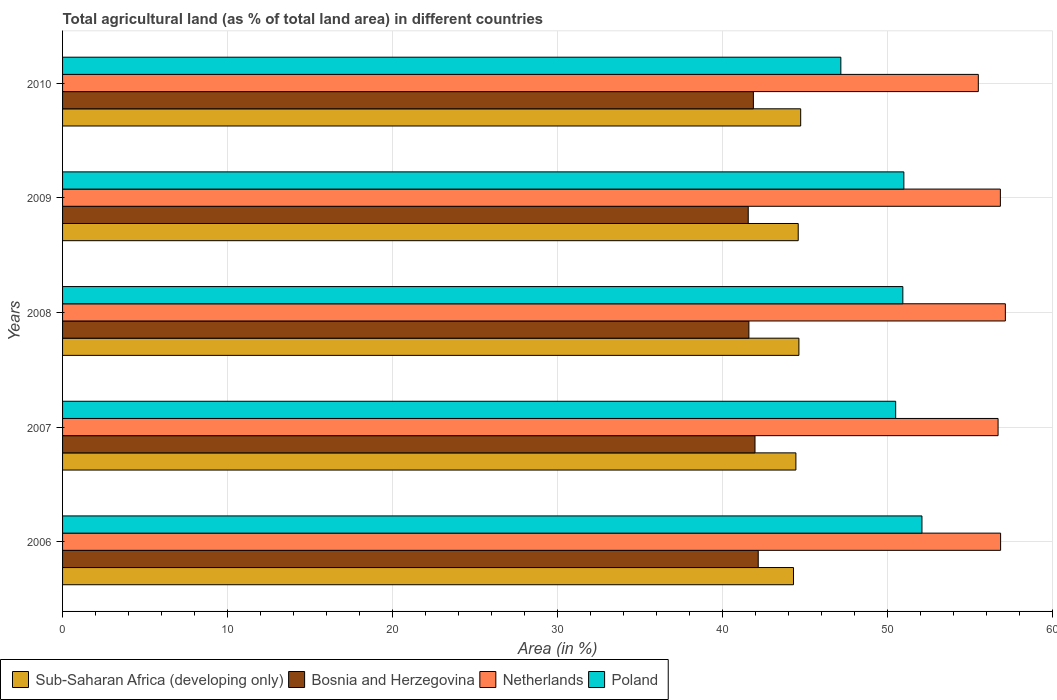How many different coloured bars are there?
Provide a succinct answer. 4. How many groups of bars are there?
Offer a terse response. 5. In how many cases, is the number of bars for a given year not equal to the number of legend labels?
Give a very brief answer. 0. What is the percentage of agricultural land in Sub-Saharan Africa (developing only) in 2010?
Give a very brief answer. 44.74. Across all years, what is the maximum percentage of agricultural land in Bosnia and Herzegovina?
Keep it short and to the point. 42.17. Across all years, what is the minimum percentage of agricultural land in Sub-Saharan Africa (developing only)?
Your response must be concise. 44.3. What is the total percentage of agricultural land in Bosnia and Herzegovina in the graph?
Keep it short and to the point. 209.18. What is the difference between the percentage of agricultural land in Bosnia and Herzegovina in 2006 and that in 2010?
Your answer should be compact. 0.29. What is the difference between the percentage of agricultural land in Netherlands in 2006 and the percentage of agricultural land in Sub-Saharan Africa (developing only) in 2009?
Make the answer very short. 12.27. What is the average percentage of agricultural land in Sub-Saharan Africa (developing only) per year?
Provide a short and direct response. 44.54. In the year 2007, what is the difference between the percentage of agricultural land in Netherlands and percentage of agricultural land in Bosnia and Herzegovina?
Offer a terse response. 14.73. What is the ratio of the percentage of agricultural land in Bosnia and Herzegovina in 2006 to that in 2008?
Keep it short and to the point. 1.01. Is the percentage of agricultural land in Bosnia and Herzegovina in 2009 less than that in 2010?
Ensure brevity in your answer.  Yes. Is the difference between the percentage of agricultural land in Netherlands in 2006 and 2009 greater than the difference between the percentage of agricultural land in Bosnia and Herzegovina in 2006 and 2009?
Your response must be concise. No. What is the difference between the highest and the second highest percentage of agricultural land in Sub-Saharan Africa (developing only)?
Provide a succinct answer. 0.11. What is the difference between the highest and the lowest percentage of agricultural land in Sub-Saharan Africa (developing only)?
Ensure brevity in your answer.  0.44. Is the sum of the percentage of agricultural land in Sub-Saharan Africa (developing only) in 2007 and 2009 greater than the maximum percentage of agricultural land in Netherlands across all years?
Give a very brief answer. Yes. Is it the case that in every year, the sum of the percentage of agricultural land in Netherlands and percentage of agricultural land in Bosnia and Herzegovina is greater than the percentage of agricultural land in Poland?
Keep it short and to the point. Yes. Are all the bars in the graph horizontal?
Offer a terse response. Yes. How many years are there in the graph?
Ensure brevity in your answer.  5. What is the difference between two consecutive major ticks on the X-axis?
Your response must be concise. 10. Are the values on the major ticks of X-axis written in scientific E-notation?
Give a very brief answer. No. Does the graph contain any zero values?
Offer a terse response. No. How are the legend labels stacked?
Your response must be concise. Horizontal. What is the title of the graph?
Offer a terse response. Total agricultural land (as % of total land area) in different countries. Does "Trinidad and Tobago" appear as one of the legend labels in the graph?
Provide a succinct answer. No. What is the label or title of the X-axis?
Give a very brief answer. Area (in %). What is the Area (in %) of Sub-Saharan Africa (developing only) in 2006?
Your answer should be compact. 44.3. What is the Area (in %) of Bosnia and Herzegovina in 2006?
Ensure brevity in your answer.  42.17. What is the Area (in %) of Netherlands in 2006?
Give a very brief answer. 56.86. What is the Area (in %) in Poland in 2006?
Offer a terse response. 52.09. What is the Area (in %) of Sub-Saharan Africa (developing only) in 2007?
Offer a terse response. 44.45. What is the Area (in %) of Bosnia and Herzegovina in 2007?
Provide a succinct answer. 41.97. What is the Area (in %) in Netherlands in 2007?
Offer a very short reply. 56.71. What is the Area (in %) in Poland in 2007?
Keep it short and to the point. 50.5. What is the Area (in %) of Sub-Saharan Africa (developing only) in 2008?
Make the answer very short. 44.63. What is the Area (in %) of Bosnia and Herzegovina in 2008?
Offer a terse response. 41.6. What is the Area (in %) in Netherlands in 2008?
Your response must be concise. 57.15. What is the Area (in %) in Poland in 2008?
Your answer should be very brief. 50.93. What is the Area (in %) of Sub-Saharan Africa (developing only) in 2009?
Your answer should be very brief. 44.59. What is the Area (in %) of Bosnia and Herzegovina in 2009?
Offer a very short reply. 41.56. What is the Area (in %) in Netherlands in 2009?
Keep it short and to the point. 56.85. What is the Area (in %) of Poland in 2009?
Make the answer very short. 51. What is the Area (in %) of Sub-Saharan Africa (developing only) in 2010?
Ensure brevity in your answer.  44.74. What is the Area (in %) in Bosnia and Herzegovina in 2010?
Keep it short and to the point. 41.88. What is the Area (in %) in Netherlands in 2010?
Provide a short and direct response. 55.51. What is the Area (in %) of Poland in 2010?
Ensure brevity in your answer.  47.18. Across all years, what is the maximum Area (in %) of Sub-Saharan Africa (developing only)?
Your answer should be compact. 44.74. Across all years, what is the maximum Area (in %) of Bosnia and Herzegovina?
Ensure brevity in your answer.  42.17. Across all years, what is the maximum Area (in %) of Netherlands?
Offer a terse response. 57.15. Across all years, what is the maximum Area (in %) of Poland?
Offer a very short reply. 52.09. Across all years, what is the minimum Area (in %) in Sub-Saharan Africa (developing only)?
Your answer should be very brief. 44.3. Across all years, what is the minimum Area (in %) of Bosnia and Herzegovina?
Your response must be concise. 41.56. Across all years, what is the minimum Area (in %) of Netherlands?
Your answer should be very brief. 55.51. Across all years, what is the minimum Area (in %) in Poland?
Provide a succinct answer. 47.18. What is the total Area (in %) of Sub-Saharan Africa (developing only) in the graph?
Offer a terse response. 222.72. What is the total Area (in %) of Bosnia and Herzegovina in the graph?
Your response must be concise. 209.18. What is the total Area (in %) of Netherlands in the graph?
Give a very brief answer. 283.07. What is the total Area (in %) of Poland in the graph?
Keep it short and to the point. 251.7. What is the difference between the Area (in %) in Sub-Saharan Africa (developing only) in 2006 and that in 2007?
Your answer should be compact. -0.15. What is the difference between the Area (in %) of Bosnia and Herzegovina in 2006 and that in 2007?
Your answer should be very brief. 0.2. What is the difference between the Area (in %) in Netherlands in 2006 and that in 2007?
Offer a terse response. 0.15. What is the difference between the Area (in %) of Poland in 2006 and that in 2007?
Your answer should be compact. 1.59. What is the difference between the Area (in %) of Sub-Saharan Africa (developing only) in 2006 and that in 2008?
Keep it short and to the point. -0.33. What is the difference between the Area (in %) in Bosnia and Herzegovina in 2006 and that in 2008?
Your answer should be very brief. 0.57. What is the difference between the Area (in %) in Netherlands in 2006 and that in 2008?
Keep it short and to the point. -0.29. What is the difference between the Area (in %) in Poland in 2006 and that in 2008?
Make the answer very short. 1.16. What is the difference between the Area (in %) in Sub-Saharan Africa (developing only) in 2006 and that in 2009?
Give a very brief answer. -0.29. What is the difference between the Area (in %) of Bosnia and Herzegovina in 2006 and that in 2009?
Keep it short and to the point. 0.61. What is the difference between the Area (in %) of Netherlands in 2006 and that in 2009?
Offer a terse response. 0.01. What is the difference between the Area (in %) in Poland in 2006 and that in 2009?
Offer a terse response. 1.1. What is the difference between the Area (in %) in Sub-Saharan Africa (developing only) in 2006 and that in 2010?
Make the answer very short. -0.44. What is the difference between the Area (in %) in Bosnia and Herzegovina in 2006 and that in 2010?
Your answer should be very brief. 0.29. What is the difference between the Area (in %) of Netherlands in 2006 and that in 2010?
Ensure brevity in your answer.  1.35. What is the difference between the Area (in %) of Poland in 2006 and that in 2010?
Ensure brevity in your answer.  4.92. What is the difference between the Area (in %) of Sub-Saharan Africa (developing only) in 2007 and that in 2008?
Ensure brevity in your answer.  -0.18. What is the difference between the Area (in %) in Bosnia and Herzegovina in 2007 and that in 2008?
Keep it short and to the point. 0.37. What is the difference between the Area (in %) of Netherlands in 2007 and that in 2008?
Give a very brief answer. -0.44. What is the difference between the Area (in %) of Poland in 2007 and that in 2008?
Give a very brief answer. -0.43. What is the difference between the Area (in %) in Sub-Saharan Africa (developing only) in 2007 and that in 2009?
Keep it short and to the point. -0.14. What is the difference between the Area (in %) in Bosnia and Herzegovina in 2007 and that in 2009?
Keep it short and to the point. 0.41. What is the difference between the Area (in %) in Netherlands in 2007 and that in 2009?
Your response must be concise. -0.14. What is the difference between the Area (in %) of Poland in 2007 and that in 2009?
Make the answer very short. -0.5. What is the difference between the Area (in %) of Sub-Saharan Africa (developing only) in 2007 and that in 2010?
Your answer should be very brief. -0.29. What is the difference between the Area (in %) in Bosnia and Herzegovina in 2007 and that in 2010?
Give a very brief answer. 0.1. What is the difference between the Area (in %) of Netherlands in 2007 and that in 2010?
Offer a very short reply. 1.2. What is the difference between the Area (in %) in Poland in 2007 and that in 2010?
Offer a terse response. 3.32. What is the difference between the Area (in %) in Sub-Saharan Africa (developing only) in 2008 and that in 2009?
Offer a terse response. 0.04. What is the difference between the Area (in %) of Bosnia and Herzegovina in 2008 and that in 2009?
Keep it short and to the point. 0.04. What is the difference between the Area (in %) in Netherlands in 2008 and that in 2009?
Give a very brief answer. 0.3. What is the difference between the Area (in %) in Poland in 2008 and that in 2009?
Make the answer very short. -0.06. What is the difference between the Area (in %) of Sub-Saharan Africa (developing only) in 2008 and that in 2010?
Offer a terse response. -0.11. What is the difference between the Area (in %) in Bosnia and Herzegovina in 2008 and that in 2010?
Keep it short and to the point. -0.27. What is the difference between the Area (in %) in Netherlands in 2008 and that in 2010?
Offer a very short reply. 1.64. What is the difference between the Area (in %) in Poland in 2008 and that in 2010?
Make the answer very short. 3.76. What is the difference between the Area (in %) of Sub-Saharan Africa (developing only) in 2009 and that in 2010?
Offer a very short reply. -0.15. What is the difference between the Area (in %) of Bosnia and Herzegovina in 2009 and that in 2010?
Keep it short and to the point. -0.31. What is the difference between the Area (in %) in Netherlands in 2009 and that in 2010?
Keep it short and to the point. 1.34. What is the difference between the Area (in %) in Poland in 2009 and that in 2010?
Offer a very short reply. 3.82. What is the difference between the Area (in %) of Sub-Saharan Africa (developing only) in 2006 and the Area (in %) of Bosnia and Herzegovina in 2007?
Your answer should be very brief. 2.33. What is the difference between the Area (in %) in Sub-Saharan Africa (developing only) in 2006 and the Area (in %) in Netherlands in 2007?
Your answer should be compact. -12.4. What is the difference between the Area (in %) in Sub-Saharan Africa (developing only) in 2006 and the Area (in %) in Poland in 2007?
Offer a terse response. -6.19. What is the difference between the Area (in %) of Bosnia and Herzegovina in 2006 and the Area (in %) of Netherlands in 2007?
Your answer should be very brief. -14.54. What is the difference between the Area (in %) of Bosnia and Herzegovina in 2006 and the Area (in %) of Poland in 2007?
Provide a succinct answer. -8.33. What is the difference between the Area (in %) in Netherlands in 2006 and the Area (in %) in Poland in 2007?
Ensure brevity in your answer.  6.36. What is the difference between the Area (in %) of Sub-Saharan Africa (developing only) in 2006 and the Area (in %) of Bosnia and Herzegovina in 2008?
Give a very brief answer. 2.7. What is the difference between the Area (in %) in Sub-Saharan Africa (developing only) in 2006 and the Area (in %) in Netherlands in 2008?
Ensure brevity in your answer.  -12.84. What is the difference between the Area (in %) in Sub-Saharan Africa (developing only) in 2006 and the Area (in %) in Poland in 2008?
Your answer should be compact. -6.63. What is the difference between the Area (in %) in Bosnia and Herzegovina in 2006 and the Area (in %) in Netherlands in 2008?
Your response must be concise. -14.98. What is the difference between the Area (in %) of Bosnia and Herzegovina in 2006 and the Area (in %) of Poland in 2008?
Provide a succinct answer. -8.77. What is the difference between the Area (in %) in Netherlands in 2006 and the Area (in %) in Poland in 2008?
Give a very brief answer. 5.93. What is the difference between the Area (in %) in Sub-Saharan Africa (developing only) in 2006 and the Area (in %) in Bosnia and Herzegovina in 2009?
Your response must be concise. 2.74. What is the difference between the Area (in %) in Sub-Saharan Africa (developing only) in 2006 and the Area (in %) in Netherlands in 2009?
Offer a terse response. -12.54. What is the difference between the Area (in %) in Sub-Saharan Africa (developing only) in 2006 and the Area (in %) in Poland in 2009?
Keep it short and to the point. -6.69. What is the difference between the Area (in %) in Bosnia and Herzegovina in 2006 and the Area (in %) in Netherlands in 2009?
Keep it short and to the point. -14.68. What is the difference between the Area (in %) of Bosnia and Herzegovina in 2006 and the Area (in %) of Poland in 2009?
Your answer should be compact. -8.83. What is the difference between the Area (in %) in Netherlands in 2006 and the Area (in %) in Poland in 2009?
Make the answer very short. 5.86. What is the difference between the Area (in %) in Sub-Saharan Africa (developing only) in 2006 and the Area (in %) in Bosnia and Herzegovina in 2010?
Provide a succinct answer. 2.43. What is the difference between the Area (in %) in Sub-Saharan Africa (developing only) in 2006 and the Area (in %) in Netherlands in 2010?
Provide a short and direct response. -11.2. What is the difference between the Area (in %) in Sub-Saharan Africa (developing only) in 2006 and the Area (in %) in Poland in 2010?
Ensure brevity in your answer.  -2.87. What is the difference between the Area (in %) in Bosnia and Herzegovina in 2006 and the Area (in %) in Netherlands in 2010?
Your answer should be very brief. -13.34. What is the difference between the Area (in %) of Bosnia and Herzegovina in 2006 and the Area (in %) of Poland in 2010?
Give a very brief answer. -5.01. What is the difference between the Area (in %) of Netherlands in 2006 and the Area (in %) of Poland in 2010?
Give a very brief answer. 9.68. What is the difference between the Area (in %) in Sub-Saharan Africa (developing only) in 2007 and the Area (in %) in Bosnia and Herzegovina in 2008?
Provide a succinct answer. 2.85. What is the difference between the Area (in %) of Sub-Saharan Africa (developing only) in 2007 and the Area (in %) of Netherlands in 2008?
Make the answer very short. -12.7. What is the difference between the Area (in %) in Sub-Saharan Africa (developing only) in 2007 and the Area (in %) in Poland in 2008?
Offer a terse response. -6.48. What is the difference between the Area (in %) of Bosnia and Herzegovina in 2007 and the Area (in %) of Netherlands in 2008?
Your response must be concise. -15.17. What is the difference between the Area (in %) in Bosnia and Herzegovina in 2007 and the Area (in %) in Poland in 2008?
Offer a terse response. -8.96. What is the difference between the Area (in %) in Netherlands in 2007 and the Area (in %) in Poland in 2008?
Your answer should be compact. 5.77. What is the difference between the Area (in %) of Sub-Saharan Africa (developing only) in 2007 and the Area (in %) of Bosnia and Herzegovina in 2009?
Offer a terse response. 2.89. What is the difference between the Area (in %) in Sub-Saharan Africa (developing only) in 2007 and the Area (in %) in Netherlands in 2009?
Your response must be concise. -12.4. What is the difference between the Area (in %) of Sub-Saharan Africa (developing only) in 2007 and the Area (in %) of Poland in 2009?
Your response must be concise. -6.55. What is the difference between the Area (in %) of Bosnia and Herzegovina in 2007 and the Area (in %) of Netherlands in 2009?
Keep it short and to the point. -14.87. What is the difference between the Area (in %) in Bosnia and Herzegovina in 2007 and the Area (in %) in Poland in 2009?
Your response must be concise. -9.02. What is the difference between the Area (in %) of Netherlands in 2007 and the Area (in %) of Poland in 2009?
Provide a succinct answer. 5.71. What is the difference between the Area (in %) in Sub-Saharan Africa (developing only) in 2007 and the Area (in %) in Bosnia and Herzegovina in 2010?
Ensure brevity in your answer.  2.58. What is the difference between the Area (in %) in Sub-Saharan Africa (developing only) in 2007 and the Area (in %) in Netherlands in 2010?
Make the answer very short. -11.06. What is the difference between the Area (in %) of Sub-Saharan Africa (developing only) in 2007 and the Area (in %) of Poland in 2010?
Your answer should be very brief. -2.73. What is the difference between the Area (in %) of Bosnia and Herzegovina in 2007 and the Area (in %) of Netherlands in 2010?
Give a very brief answer. -13.54. What is the difference between the Area (in %) in Bosnia and Herzegovina in 2007 and the Area (in %) in Poland in 2010?
Ensure brevity in your answer.  -5.2. What is the difference between the Area (in %) in Netherlands in 2007 and the Area (in %) in Poland in 2010?
Offer a very short reply. 9.53. What is the difference between the Area (in %) of Sub-Saharan Africa (developing only) in 2008 and the Area (in %) of Bosnia and Herzegovina in 2009?
Make the answer very short. 3.07. What is the difference between the Area (in %) of Sub-Saharan Africa (developing only) in 2008 and the Area (in %) of Netherlands in 2009?
Offer a very short reply. -12.21. What is the difference between the Area (in %) in Sub-Saharan Africa (developing only) in 2008 and the Area (in %) in Poland in 2009?
Your answer should be compact. -6.36. What is the difference between the Area (in %) in Bosnia and Herzegovina in 2008 and the Area (in %) in Netherlands in 2009?
Your response must be concise. -15.24. What is the difference between the Area (in %) in Bosnia and Herzegovina in 2008 and the Area (in %) in Poland in 2009?
Provide a short and direct response. -9.39. What is the difference between the Area (in %) of Netherlands in 2008 and the Area (in %) of Poland in 2009?
Your answer should be compact. 6.15. What is the difference between the Area (in %) of Sub-Saharan Africa (developing only) in 2008 and the Area (in %) of Bosnia and Herzegovina in 2010?
Ensure brevity in your answer.  2.76. What is the difference between the Area (in %) in Sub-Saharan Africa (developing only) in 2008 and the Area (in %) in Netherlands in 2010?
Your answer should be very brief. -10.88. What is the difference between the Area (in %) in Sub-Saharan Africa (developing only) in 2008 and the Area (in %) in Poland in 2010?
Provide a short and direct response. -2.54. What is the difference between the Area (in %) in Bosnia and Herzegovina in 2008 and the Area (in %) in Netherlands in 2010?
Provide a short and direct response. -13.91. What is the difference between the Area (in %) in Bosnia and Herzegovina in 2008 and the Area (in %) in Poland in 2010?
Provide a short and direct response. -5.57. What is the difference between the Area (in %) in Netherlands in 2008 and the Area (in %) in Poland in 2010?
Provide a succinct answer. 9.97. What is the difference between the Area (in %) of Sub-Saharan Africa (developing only) in 2009 and the Area (in %) of Bosnia and Herzegovina in 2010?
Give a very brief answer. 2.72. What is the difference between the Area (in %) in Sub-Saharan Africa (developing only) in 2009 and the Area (in %) in Netherlands in 2010?
Provide a succinct answer. -10.92. What is the difference between the Area (in %) in Sub-Saharan Africa (developing only) in 2009 and the Area (in %) in Poland in 2010?
Provide a short and direct response. -2.58. What is the difference between the Area (in %) of Bosnia and Herzegovina in 2009 and the Area (in %) of Netherlands in 2010?
Provide a succinct answer. -13.95. What is the difference between the Area (in %) in Bosnia and Herzegovina in 2009 and the Area (in %) in Poland in 2010?
Your response must be concise. -5.61. What is the difference between the Area (in %) in Netherlands in 2009 and the Area (in %) in Poland in 2010?
Offer a terse response. 9.67. What is the average Area (in %) of Sub-Saharan Africa (developing only) per year?
Offer a very short reply. 44.54. What is the average Area (in %) in Bosnia and Herzegovina per year?
Your answer should be compact. 41.84. What is the average Area (in %) in Netherlands per year?
Your answer should be compact. 56.61. What is the average Area (in %) in Poland per year?
Offer a terse response. 50.34. In the year 2006, what is the difference between the Area (in %) in Sub-Saharan Africa (developing only) and Area (in %) in Bosnia and Herzegovina?
Offer a very short reply. 2.14. In the year 2006, what is the difference between the Area (in %) of Sub-Saharan Africa (developing only) and Area (in %) of Netherlands?
Make the answer very short. -12.56. In the year 2006, what is the difference between the Area (in %) in Sub-Saharan Africa (developing only) and Area (in %) in Poland?
Your response must be concise. -7.79. In the year 2006, what is the difference between the Area (in %) in Bosnia and Herzegovina and Area (in %) in Netherlands?
Your answer should be compact. -14.69. In the year 2006, what is the difference between the Area (in %) of Bosnia and Herzegovina and Area (in %) of Poland?
Offer a very short reply. -9.92. In the year 2006, what is the difference between the Area (in %) in Netherlands and Area (in %) in Poland?
Your answer should be very brief. 4.77. In the year 2007, what is the difference between the Area (in %) of Sub-Saharan Africa (developing only) and Area (in %) of Bosnia and Herzegovina?
Your answer should be very brief. 2.48. In the year 2007, what is the difference between the Area (in %) in Sub-Saharan Africa (developing only) and Area (in %) in Netherlands?
Offer a terse response. -12.26. In the year 2007, what is the difference between the Area (in %) of Sub-Saharan Africa (developing only) and Area (in %) of Poland?
Your response must be concise. -6.05. In the year 2007, what is the difference between the Area (in %) of Bosnia and Herzegovina and Area (in %) of Netherlands?
Your answer should be very brief. -14.73. In the year 2007, what is the difference between the Area (in %) in Bosnia and Herzegovina and Area (in %) in Poland?
Keep it short and to the point. -8.53. In the year 2007, what is the difference between the Area (in %) in Netherlands and Area (in %) in Poland?
Give a very brief answer. 6.21. In the year 2008, what is the difference between the Area (in %) of Sub-Saharan Africa (developing only) and Area (in %) of Bosnia and Herzegovina?
Keep it short and to the point. 3.03. In the year 2008, what is the difference between the Area (in %) in Sub-Saharan Africa (developing only) and Area (in %) in Netherlands?
Your answer should be compact. -12.51. In the year 2008, what is the difference between the Area (in %) of Sub-Saharan Africa (developing only) and Area (in %) of Poland?
Offer a terse response. -6.3. In the year 2008, what is the difference between the Area (in %) of Bosnia and Herzegovina and Area (in %) of Netherlands?
Keep it short and to the point. -15.55. In the year 2008, what is the difference between the Area (in %) in Bosnia and Herzegovina and Area (in %) in Poland?
Your answer should be compact. -9.33. In the year 2008, what is the difference between the Area (in %) in Netherlands and Area (in %) in Poland?
Provide a short and direct response. 6.21. In the year 2009, what is the difference between the Area (in %) of Sub-Saharan Africa (developing only) and Area (in %) of Bosnia and Herzegovina?
Provide a short and direct response. 3.03. In the year 2009, what is the difference between the Area (in %) of Sub-Saharan Africa (developing only) and Area (in %) of Netherlands?
Your answer should be compact. -12.25. In the year 2009, what is the difference between the Area (in %) in Sub-Saharan Africa (developing only) and Area (in %) in Poland?
Your answer should be compact. -6.4. In the year 2009, what is the difference between the Area (in %) of Bosnia and Herzegovina and Area (in %) of Netherlands?
Ensure brevity in your answer.  -15.28. In the year 2009, what is the difference between the Area (in %) of Bosnia and Herzegovina and Area (in %) of Poland?
Your response must be concise. -9.43. In the year 2009, what is the difference between the Area (in %) of Netherlands and Area (in %) of Poland?
Provide a succinct answer. 5.85. In the year 2010, what is the difference between the Area (in %) of Sub-Saharan Africa (developing only) and Area (in %) of Bosnia and Herzegovina?
Keep it short and to the point. 2.87. In the year 2010, what is the difference between the Area (in %) of Sub-Saharan Africa (developing only) and Area (in %) of Netherlands?
Offer a very short reply. -10.77. In the year 2010, what is the difference between the Area (in %) of Sub-Saharan Africa (developing only) and Area (in %) of Poland?
Your response must be concise. -2.43. In the year 2010, what is the difference between the Area (in %) of Bosnia and Herzegovina and Area (in %) of Netherlands?
Ensure brevity in your answer.  -13.63. In the year 2010, what is the difference between the Area (in %) in Bosnia and Herzegovina and Area (in %) in Poland?
Your answer should be compact. -5.3. In the year 2010, what is the difference between the Area (in %) in Netherlands and Area (in %) in Poland?
Your answer should be very brief. 8.33. What is the ratio of the Area (in %) of Bosnia and Herzegovina in 2006 to that in 2007?
Your answer should be compact. 1. What is the ratio of the Area (in %) in Poland in 2006 to that in 2007?
Give a very brief answer. 1.03. What is the ratio of the Area (in %) in Bosnia and Herzegovina in 2006 to that in 2008?
Ensure brevity in your answer.  1.01. What is the ratio of the Area (in %) of Netherlands in 2006 to that in 2008?
Your answer should be compact. 0.99. What is the ratio of the Area (in %) in Poland in 2006 to that in 2008?
Your answer should be compact. 1.02. What is the ratio of the Area (in %) of Sub-Saharan Africa (developing only) in 2006 to that in 2009?
Keep it short and to the point. 0.99. What is the ratio of the Area (in %) in Bosnia and Herzegovina in 2006 to that in 2009?
Give a very brief answer. 1.01. What is the ratio of the Area (in %) in Poland in 2006 to that in 2009?
Make the answer very short. 1.02. What is the ratio of the Area (in %) of Sub-Saharan Africa (developing only) in 2006 to that in 2010?
Provide a succinct answer. 0.99. What is the ratio of the Area (in %) of Netherlands in 2006 to that in 2010?
Keep it short and to the point. 1.02. What is the ratio of the Area (in %) in Poland in 2006 to that in 2010?
Offer a terse response. 1.1. What is the ratio of the Area (in %) in Bosnia and Herzegovina in 2007 to that in 2008?
Ensure brevity in your answer.  1.01. What is the ratio of the Area (in %) of Netherlands in 2007 to that in 2008?
Ensure brevity in your answer.  0.99. What is the ratio of the Area (in %) of Poland in 2007 to that in 2008?
Your answer should be compact. 0.99. What is the ratio of the Area (in %) in Sub-Saharan Africa (developing only) in 2007 to that in 2009?
Give a very brief answer. 1. What is the ratio of the Area (in %) of Bosnia and Herzegovina in 2007 to that in 2009?
Make the answer very short. 1.01. What is the ratio of the Area (in %) of Poland in 2007 to that in 2009?
Your answer should be compact. 0.99. What is the ratio of the Area (in %) of Sub-Saharan Africa (developing only) in 2007 to that in 2010?
Your response must be concise. 0.99. What is the ratio of the Area (in %) in Bosnia and Herzegovina in 2007 to that in 2010?
Your answer should be very brief. 1. What is the ratio of the Area (in %) in Netherlands in 2007 to that in 2010?
Provide a short and direct response. 1.02. What is the ratio of the Area (in %) in Poland in 2007 to that in 2010?
Offer a very short reply. 1.07. What is the ratio of the Area (in %) in Bosnia and Herzegovina in 2008 to that in 2009?
Your response must be concise. 1. What is the ratio of the Area (in %) of Sub-Saharan Africa (developing only) in 2008 to that in 2010?
Make the answer very short. 1. What is the ratio of the Area (in %) in Bosnia and Herzegovina in 2008 to that in 2010?
Keep it short and to the point. 0.99. What is the ratio of the Area (in %) in Netherlands in 2008 to that in 2010?
Offer a terse response. 1.03. What is the ratio of the Area (in %) of Poland in 2008 to that in 2010?
Give a very brief answer. 1.08. What is the ratio of the Area (in %) in Sub-Saharan Africa (developing only) in 2009 to that in 2010?
Ensure brevity in your answer.  1. What is the ratio of the Area (in %) of Netherlands in 2009 to that in 2010?
Offer a terse response. 1.02. What is the ratio of the Area (in %) of Poland in 2009 to that in 2010?
Make the answer very short. 1.08. What is the difference between the highest and the second highest Area (in %) of Sub-Saharan Africa (developing only)?
Offer a very short reply. 0.11. What is the difference between the highest and the second highest Area (in %) in Bosnia and Herzegovina?
Your answer should be compact. 0.2. What is the difference between the highest and the second highest Area (in %) of Netherlands?
Offer a very short reply. 0.29. What is the difference between the highest and the second highest Area (in %) of Poland?
Keep it short and to the point. 1.1. What is the difference between the highest and the lowest Area (in %) in Sub-Saharan Africa (developing only)?
Offer a terse response. 0.44. What is the difference between the highest and the lowest Area (in %) in Bosnia and Herzegovina?
Your answer should be very brief. 0.61. What is the difference between the highest and the lowest Area (in %) of Netherlands?
Your response must be concise. 1.64. What is the difference between the highest and the lowest Area (in %) of Poland?
Your answer should be compact. 4.92. 